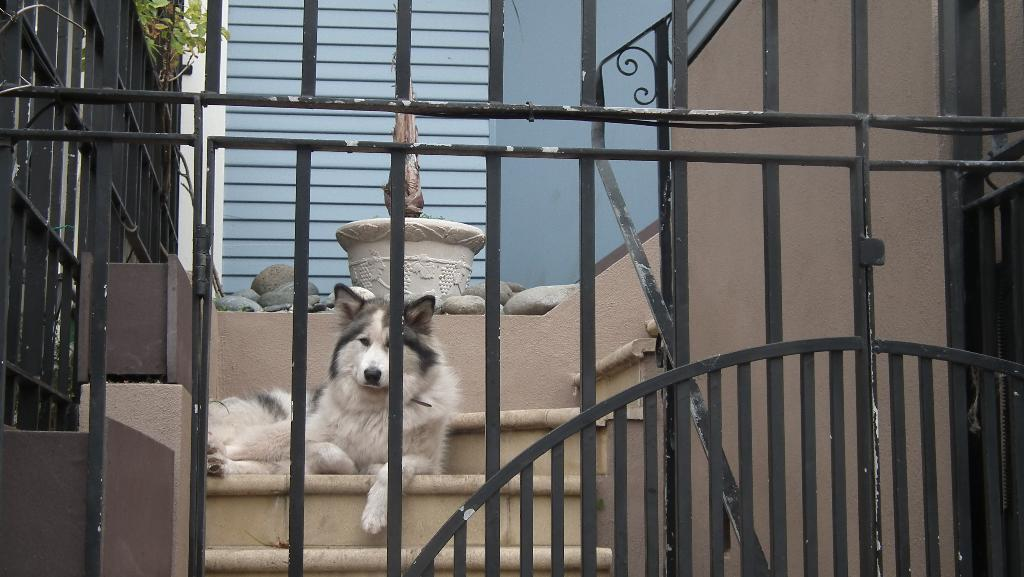What type of animal is in the image? There is a dog in the image. Can you describe the color of the dog? The dog is white and gray in color. What architectural feature is visible in the image? There are stairs visible in the image. What type of vegetation is present in the image? There are plants with green color in the image. What is the purpose of the railing in the image? The railing is likely for safety or support while using the stairs. How does the creature wash its hands in the image? There is no creature present in the image, and therefore no hand-washing activity can be observed. 